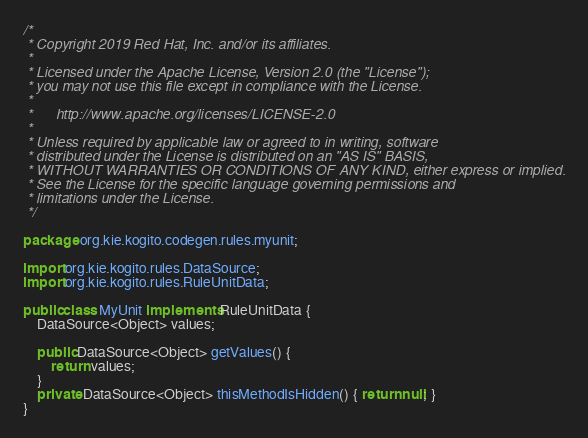Convert code to text. <code><loc_0><loc_0><loc_500><loc_500><_Java_>/*
 * Copyright 2019 Red Hat, Inc. and/or its affiliates.
 *
 * Licensed under the Apache License, Version 2.0 (the "License");
 * you may not use this file except in compliance with the License.
 *
 *      http://www.apache.org/licenses/LICENSE-2.0
 *
 * Unless required by applicable law or agreed to in writing, software
 * distributed under the License is distributed on an "AS IS" BASIS,
 * WITHOUT WARRANTIES OR CONDITIONS OF ANY KIND, either express or implied.
 * See the License for the specific language governing permissions and
 * limitations under the License.
 */

package org.kie.kogito.codegen.rules.myunit;

import org.kie.kogito.rules.DataSource;
import org.kie.kogito.rules.RuleUnitData;

public class MyUnit implements RuleUnitData {
    DataSource<Object> values;

    public DataSource<Object> getValues() {
        return values;
    }
    private DataSource<Object> thisMethodIsHidden() { return null; }
}
</code> 